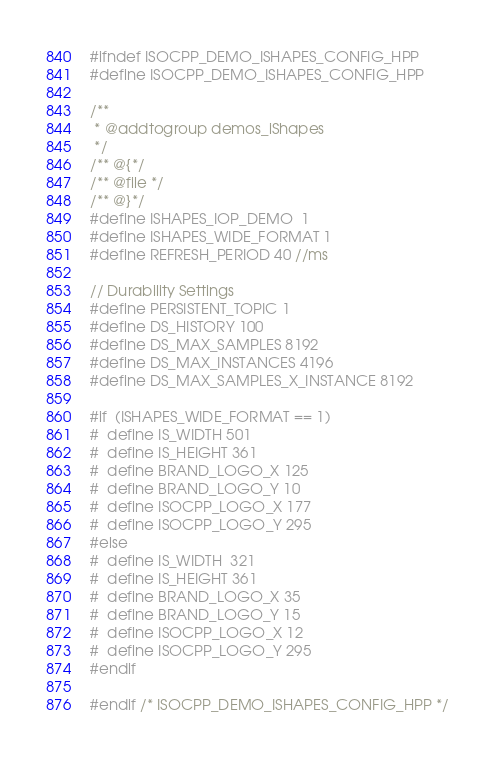<code> <loc_0><loc_0><loc_500><loc_500><_C++_>#ifndef ISOCPP_DEMO_ISHAPES_CONFIG_HPP
#define ISOCPP_DEMO_ISHAPES_CONFIG_HPP

/**
 * @addtogroup demos_iShapes
 */
/** @{*/
/** @file */
/** @}*/
#define ISHAPES_IOP_DEMO  1
#define ISHAPES_WIDE_FORMAT 1
#define REFRESH_PERIOD 40 //ms

// Durability Settings
#define PERSISTENT_TOPIC 1
#define DS_HISTORY 100
#define DS_MAX_SAMPLES 8192
#define DS_MAX_INSTANCES 4196
#define DS_MAX_SAMPLES_X_INSTANCE 8192

#if  (ISHAPES_WIDE_FORMAT == 1)
#  define IS_WIDTH 501
#  define IS_HEIGHT 361
#  define BRAND_LOGO_X 125
#  define BRAND_LOGO_Y 10
#  define ISOCPP_LOGO_X 177
#  define ISOCPP_LOGO_Y 295
#else
#  define IS_WIDTH  321
#  define IS_HEIGHT 361
#  define BRAND_LOGO_X 35
#  define BRAND_LOGO_Y 15
#  define ISOCPP_LOGO_X 12
#  define ISOCPP_LOGO_Y 295
#endif

#endif /* ISOCPP_DEMO_ISHAPES_CONFIG_HPP */
</code> 